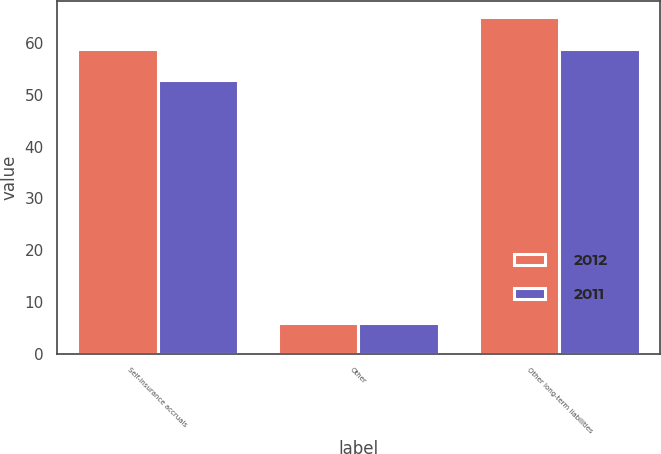Convert chart to OTSL. <chart><loc_0><loc_0><loc_500><loc_500><stacked_bar_chart><ecel><fcel>Self-insurance accruals<fcel>Other<fcel>Other long-term liabilities<nl><fcel>2012<fcel>59<fcel>6<fcel>65<nl><fcel>2011<fcel>53<fcel>6<fcel>59<nl></chart> 